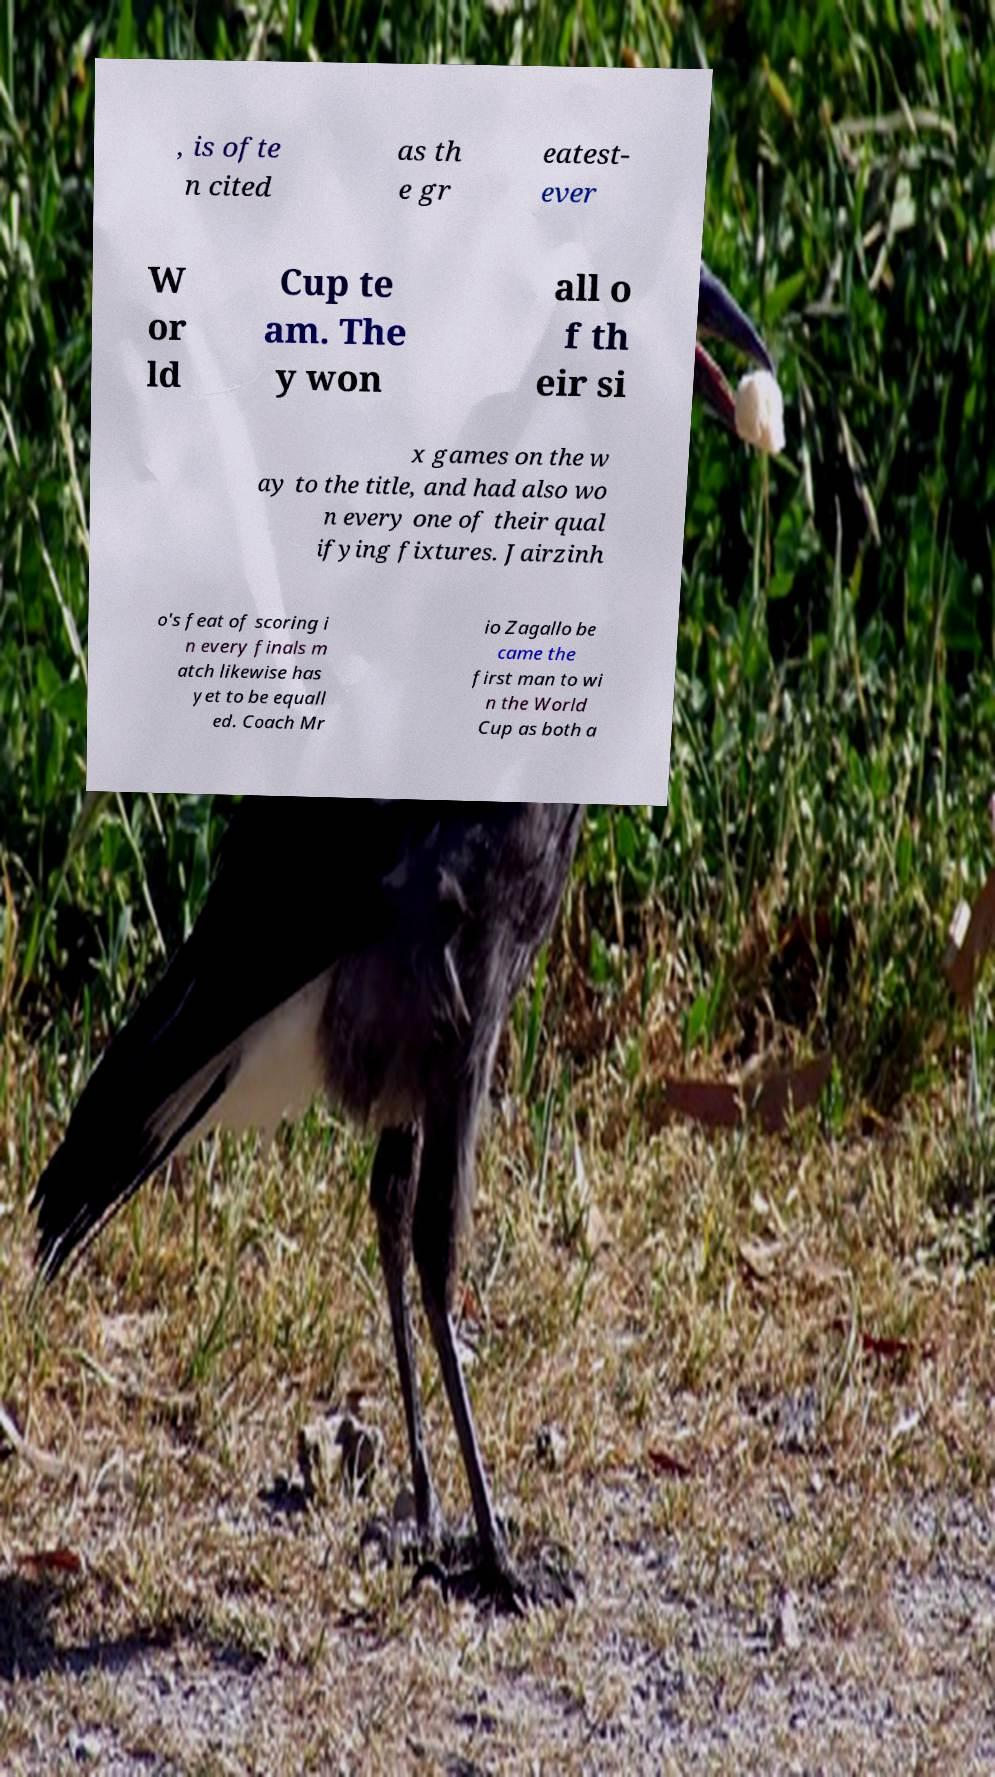Please read and relay the text visible in this image. What does it say? , is ofte n cited as th e gr eatest- ever W or ld Cup te am. The y won all o f th eir si x games on the w ay to the title, and had also wo n every one of their qual ifying fixtures. Jairzinh o's feat of scoring i n every finals m atch likewise has yet to be equall ed. Coach Mr io Zagallo be came the first man to wi n the World Cup as both a 